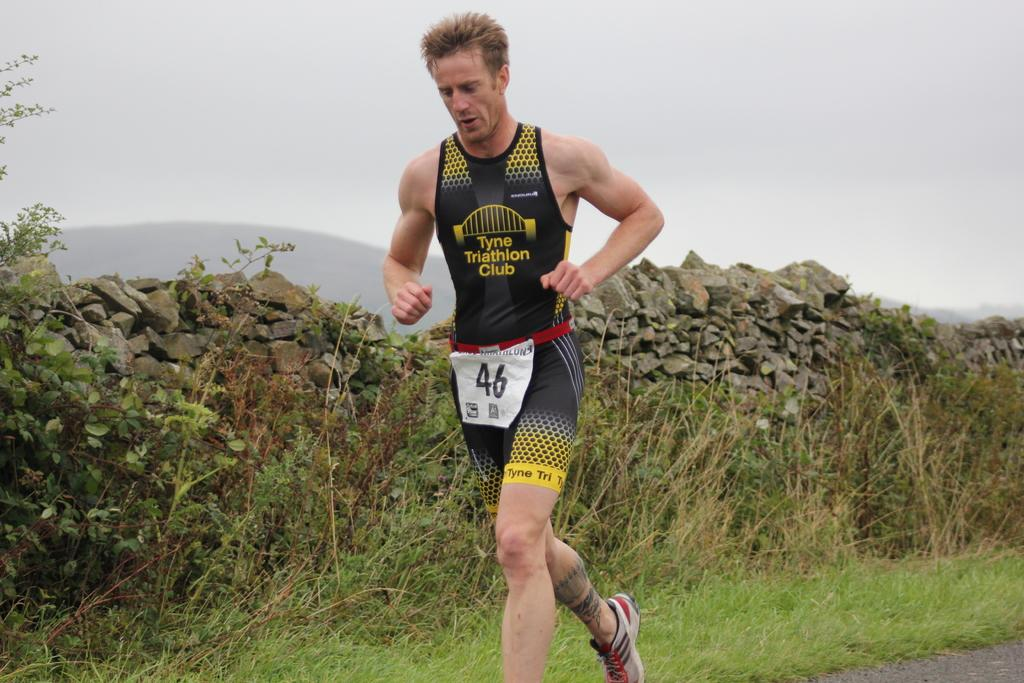<image>
Give a short and clear explanation of the subsequent image. Running athlete with black and gray shorts with Tyne Triathlon Club in yellow lettering on his jersey. 